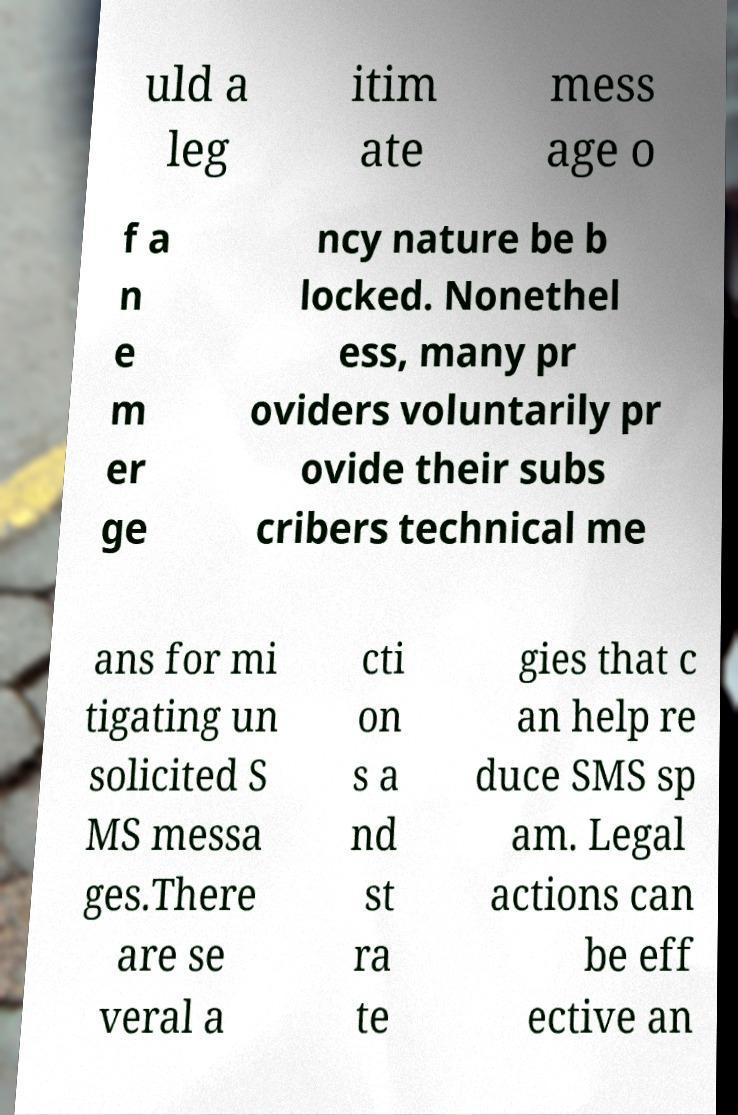Could you extract and type out the text from this image? uld a leg itim ate mess age o f a n e m er ge ncy nature be b locked. Nonethel ess, many pr oviders voluntarily pr ovide their subs cribers technical me ans for mi tigating un solicited S MS messa ges.There are se veral a cti on s a nd st ra te gies that c an help re duce SMS sp am. Legal actions can be eff ective an 